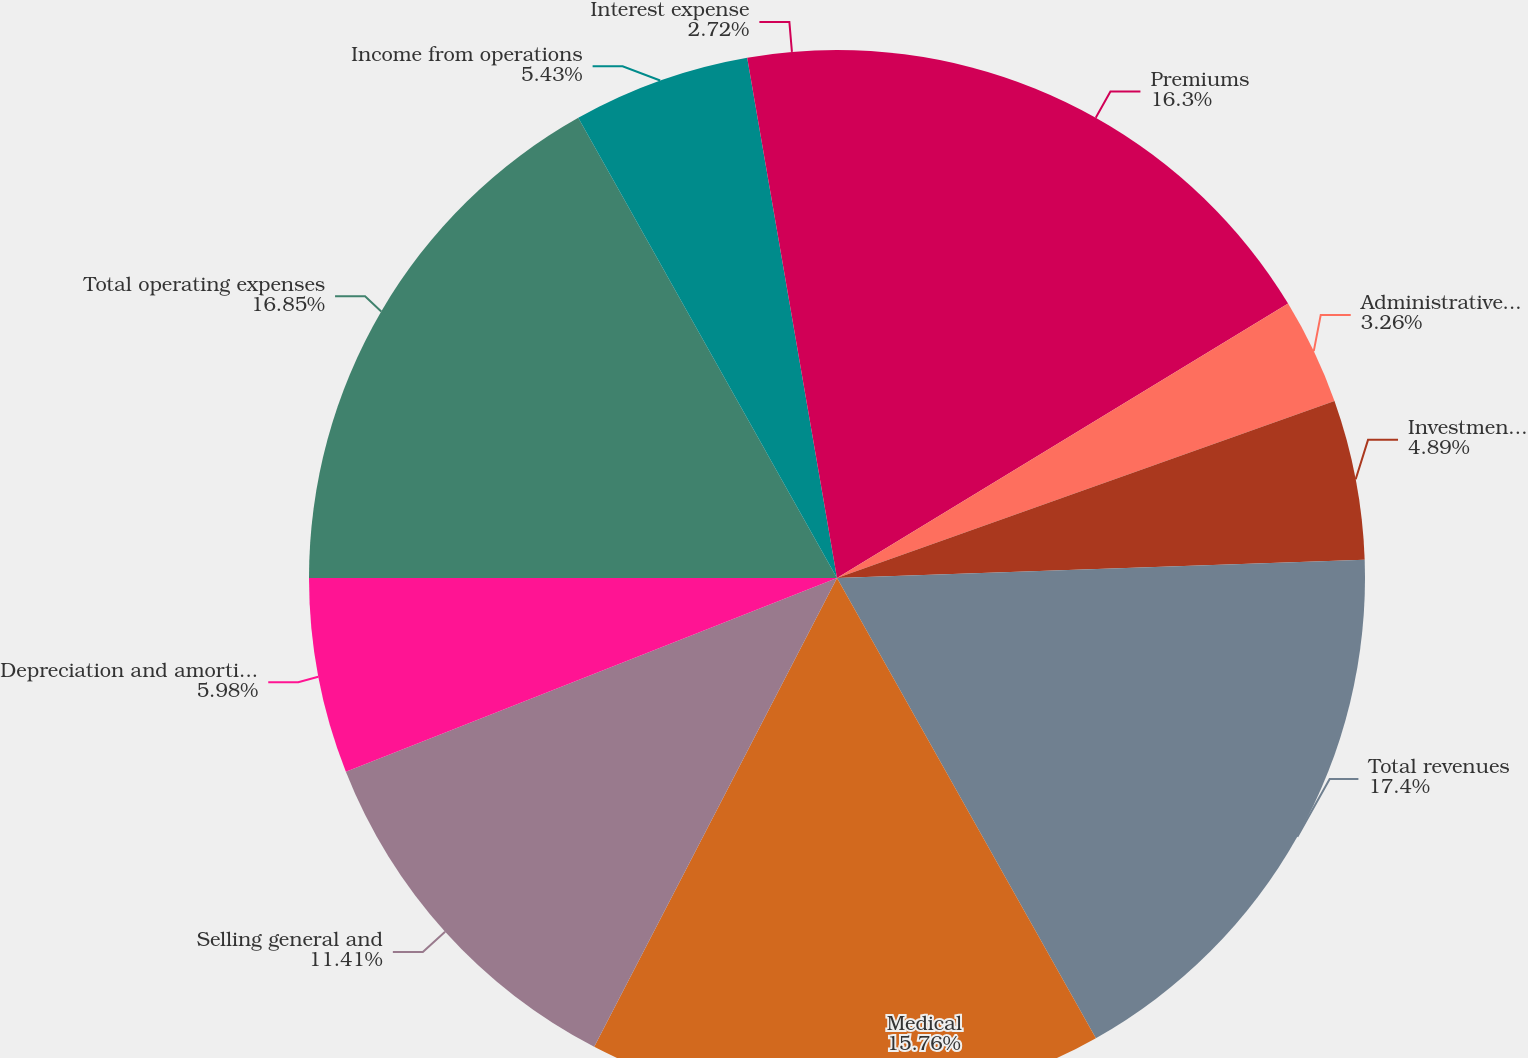Convert chart. <chart><loc_0><loc_0><loc_500><loc_500><pie_chart><fcel>Premiums<fcel>Administrative services fees<fcel>Investment and other income<fcel>Total revenues<fcel>Medical<fcel>Selling general and<fcel>Depreciation and amortization<fcel>Total operating expenses<fcel>Income from operations<fcel>Interest expense<nl><fcel>16.3%<fcel>3.26%<fcel>4.89%<fcel>17.39%<fcel>15.76%<fcel>11.41%<fcel>5.98%<fcel>16.85%<fcel>5.43%<fcel>2.72%<nl></chart> 